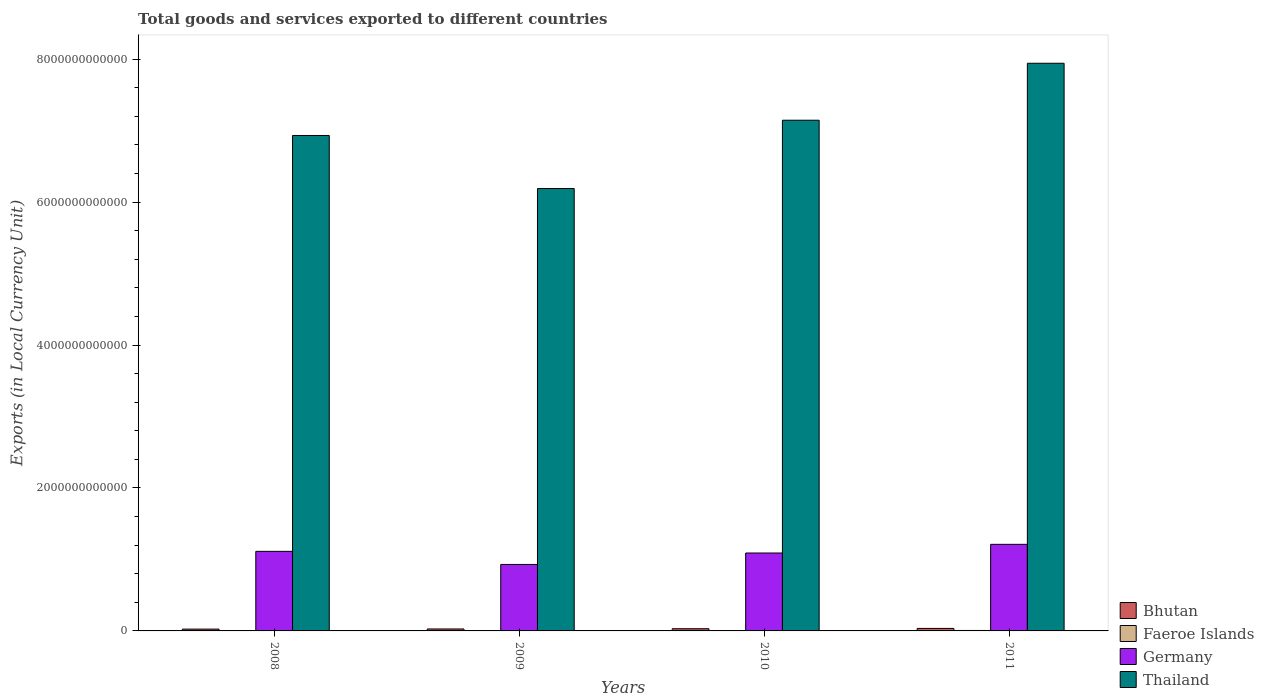How many different coloured bars are there?
Provide a short and direct response. 4. How many groups of bars are there?
Your response must be concise. 4. How many bars are there on the 4th tick from the left?
Keep it short and to the point. 4. What is the label of the 3rd group of bars from the left?
Offer a very short reply. 2010. What is the Amount of goods and services exports in Thailand in 2010?
Provide a short and direct response. 7.15e+12. Across all years, what is the maximum Amount of goods and services exports in Thailand?
Keep it short and to the point. 7.94e+12. Across all years, what is the minimum Amount of goods and services exports in Thailand?
Offer a very short reply. 6.19e+12. In which year was the Amount of goods and services exports in Faeroe Islands minimum?
Give a very brief answer. 2009. What is the total Amount of goods and services exports in Germany in the graph?
Your answer should be compact. 4.34e+12. What is the difference between the Amount of goods and services exports in Germany in 2008 and that in 2009?
Your response must be concise. 1.83e+11. What is the difference between the Amount of goods and services exports in Germany in 2008 and the Amount of goods and services exports in Bhutan in 2009?
Your answer should be very brief. 1.09e+12. What is the average Amount of goods and services exports in Germany per year?
Your response must be concise. 1.09e+12. In the year 2008, what is the difference between the Amount of goods and services exports in Bhutan and Amount of goods and services exports in Faeroe Islands?
Provide a short and direct response. 1.99e+1. What is the ratio of the Amount of goods and services exports in Germany in 2008 to that in 2010?
Offer a very short reply. 1.02. Is the Amount of goods and services exports in Faeroe Islands in 2010 less than that in 2011?
Offer a terse response. Yes. What is the difference between the highest and the second highest Amount of goods and services exports in Faeroe Islands?
Give a very brief answer. 7.42e+08. What is the difference between the highest and the lowest Amount of goods and services exports in Thailand?
Provide a succinct answer. 1.75e+12. In how many years, is the Amount of goods and services exports in Germany greater than the average Amount of goods and services exports in Germany taken over all years?
Your response must be concise. 3. Is the sum of the Amount of goods and services exports in Germany in 2009 and 2011 greater than the maximum Amount of goods and services exports in Faeroe Islands across all years?
Give a very brief answer. Yes. What does the 4th bar from the left in 2008 represents?
Ensure brevity in your answer.  Thailand. What does the 3rd bar from the right in 2009 represents?
Give a very brief answer. Faeroe Islands. What is the difference between two consecutive major ticks on the Y-axis?
Your answer should be compact. 2.00e+12. Are the values on the major ticks of Y-axis written in scientific E-notation?
Make the answer very short. No. Does the graph contain any zero values?
Keep it short and to the point. No. Where does the legend appear in the graph?
Provide a succinct answer. Bottom right. What is the title of the graph?
Provide a short and direct response. Total goods and services exported to different countries. Does "Bolivia" appear as one of the legend labels in the graph?
Give a very brief answer. No. What is the label or title of the Y-axis?
Your answer should be very brief. Exports (in Local Currency Unit). What is the Exports (in Local Currency Unit) of Bhutan in 2008?
Provide a short and direct response. 2.55e+1. What is the Exports (in Local Currency Unit) in Faeroe Islands in 2008?
Make the answer very short. 5.63e+09. What is the Exports (in Local Currency Unit) in Germany in 2008?
Keep it short and to the point. 1.11e+12. What is the Exports (in Local Currency Unit) of Thailand in 2008?
Your answer should be compact. 6.93e+12. What is the Exports (in Local Currency Unit) of Bhutan in 2009?
Offer a very short reply. 2.74e+1. What is the Exports (in Local Currency Unit) in Faeroe Islands in 2009?
Offer a terse response. 5.01e+09. What is the Exports (in Local Currency Unit) of Germany in 2009?
Make the answer very short. 9.30e+11. What is the Exports (in Local Currency Unit) of Thailand in 2009?
Provide a succinct answer. 6.19e+12. What is the Exports (in Local Currency Unit) in Bhutan in 2010?
Offer a very short reply. 3.08e+1. What is the Exports (in Local Currency Unit) in Faeroe Islands in 2010?
Make the answer very short. 5.77e+09. What is the Exports (in Local Currency Unit) in Germany in 2010?
Give a very brief answer. 1.09e+12. What is the Exports (in Local Currency Unit) in Thailand in 2010?
Offer a terse response. 7.15e+12. What is the Exports (in Local Currency Unit) in Bhutan in 2011?
Make the answer very short. 3.50e+1. What is the Exports (in Local Currency Unit) in Faeroe Islands in 2011?
Ensure brevity in your answer.  6.51e+09. What is the Exports (in Local Currency Unit) of Germany in 2011?
Provide a succinct answer. 1.21e+12. What is the Exports (in Local Currency Unit) in Thailand in 2011?
Give a very brief answer. 7.94e+12. Across all years, what is the maximum Exports (in Local Currency Unit) in Bhutan?
Your answer should be compact. 3.50e+1. Across all years, what is the maximum Exports (in Local Currency Unit) of Faeroe Islands?
Offer a terse response. 6.51e+09. Across all years, what is the maximum Exports (in Local Currency Unit) of Germany?
Offer a terse response. 1.21e+12. Across all years, what is the maximum Exports (in Local Currency Unit) of Thailand?
Provide a succinct answer. 7.94e+12. Across all years, what is the minimum Exports (in Local Currency Unit) of Bhutan?
Offer a very short reply. 2.55e+1. Across all years, what is the minimum Exports (in Local Currency Unit) in Faeroe Islands?
Offer a very short reply. 5.01e+09. Across all years, what is the minimum Exports (in Local Currency Unit) in Germany?
Your answer should be very brief. 9.30e+11. Across all years, what is the minimum Exports (in Local Currency Unit) of Thailand?
Provide a succinct answer. 6.19e+12. What is the total Exports (in Local Currency Unit) in Bhutan in the graph?
Offer a very short reply. 1.19e+11. What is the total Exports (in Local Currency Unit) in Faeroe Islands in the graph?
Make the answer very short. 2.29e+1. What is the total Exports (in Local Currency Unit) of Germany in the graph?
Your answer should be compact. 4.34e+12. What is the total Exports (in Local Currency Unit) in Thailand in the graph?
Offer a very short reply. 2.82e+13. What is the difference between the Exports (in Local Currency Unit) in Bhutan in 2008 and that in 2009?
Your response must be concise. -1.88e+09. What is the difference between the Exports (in Local Currency Unit) of Faeroe Islands in 2008 and that in 2009?
Provide a short and direct response. 6.21e+08. What is the difference between the Exports (in Local Currency Unit) of Germany in 2008 and that in 2009?
Give a very brief answer. 1.83e+11. What is the difference between the Exports (in Local Currency Unit) of Thailand in 2008 and that in 2009?
Provide a succinct answer. 7.42e+11. What is the difference between the Exports (in Local Currency Unit) in Bhutan in 2008 and that in 2010?
Provide a succinct answer. -5.29e+09. What is the difference between the Exports (in Local Currency Unit) in Faeroe Islands in 2008 and that in 2010?
Keep it short and to the point. -1.39e+08. What is the difference between the Exports (in Local Currency Unit) in Germany in 2008 and that in 2010?
Provide a short and direct response. 2.32e+1. What is the difference between the Exports (in Local Currency Unit) in Thailand in 2008 and that in 2010?
Keep it short and to the point. -2.13e+11. What is the difference between the Exports (in Local Currency Unit) in Bhutan in 2008 and that in 2011?
Offer a terse response. -9.52e+09. What is the difference between the Exports (in Local Currency Unit) of Faeroe Islands in 2008 and that in 2011?
Keep it short and to the point. -8.81e+08. What is the difference between the Exports (in Local Currency Unit) of Germany in 2008 and that in 2011?
Offer a very short reply. -9.82e+1. What is the difference between the Exports (in Local Currency Unit) of Thailand in 2008 and that in 2011?
Give a very brief answer. -1.01e+12. What is the difference between the Exports (in Local Currency Unit) of Bhutan in 2009 and that in 2010?
Offer a terse response. -3.41e+09. What is the difference between the Exports (in Local Currency Unit) in Faeroe Islands in 2009 and that in 2010?
Give a very brief answer. -7.60e+08. What is the difference between the Exports (in Local Currency Unit) of Germany in 2009 and that in 2010?
Keep it short and to the point. -1.60e+11. What is the difference between the Exports (in Local Currency Unit) in Thailand in 2009 and that in 2010?
Your response must be concise. -9.55e+11. What is the difference between the Exports (in Local Currency Unit) in Bhutan in 2009 and that in 2011?
Your answer should be compact. -7.64e+09. What is the difference between the Exports (in Local Currency Unit) of Faeroe Islands in 2009 and that in 2011?
Give a very brief answer. -1.50e+09. What is the difference between the Exports (in Local Currency Unit) in Germany in 2009 and that in 2011?
Give a very brief answer. -2.81e+11. What is the difference between the Exports (in Local Currency Unit) of Thailand in 2009 and that in 2011?
Ensure brevity in your answer.  -1.75e+12. What is the difference between the Exports (in Local Currency Unit) of Bhutan in 2010 and that in 2011?
Your answer should be compact. -4.23e+09. What is the difference between the Exports (in Local Currency Unit) of Faeroe Islands in 2010 and that in 2011?
Offer a terse response. -7.42e+08. What is the difference between the Exports (in Local Currency Unit) of Germany in 2010 and that in 2011?
Give a very brief answer. -1.21e+11. What is the difference between the Exports (in Local Currency Unit) of Thailand in 2010 and that in 2011?
Provide a succinct answer. -7.97e+11. What is the difference between the Exports (in Local Currency Unit) in Bhutan in 2008 and the Exports (in Local Currency Unit) in Faeroe Islands in 2009?
Make the answer very short. 2.05e+1. What is the difference between the Exports (in Local Currency Unit) of Bhutan in 2008 and the Exports (in Local Currency Unit) of Germany in 2009?
Your response must be concise. -9.05e+11. What is the difference between the Exports (in Local Currency Unit) of Bhutan in 2008 and the Exports (in Local Currency Unit) of Thailand in 2009?
Give a very brief answer. -6.16e+12. What is the difference between the Exports (in Local Currency Unit) of Faeroe Islands in 2008 and the Exports (in Local Currency Unit) of Germany in 2009?
Offer a very short reply. -9.24e+11. What is the difference between the Exports (in Local Currency Unit) of Faeroe Islands in 2008 and the Exports (in Local Currency Unit) of Thailand in 2009?
Ensure brevity in your answer.  -6.18e+12. What is the difference between the Exports (in Local Currency Unit) of Germany in 2008 and the Exports (in Local Currency Unit) of Thailand in 2009?
Give a very brief answer. -5.08e+12. What is the difference between the Exports (in Local Currency Unit) of Bhutan in 2008 and the Exports (in Local Currency Unit) of Faeroe Islands in 2010?
Your answer should be very brief. 1.97e+1. What is the difference between the Exports (in Local Currency Unit) of Bhutan in 2008 and the Exports (in Local Currency Unit) of Germany in 2010?
Give a very brief answer. -1.06e+12. What is the difference between the Exports (in Local Currency Unit) of Bhutan in 2008 and the Exports (in Local Currency Unit) of Thailand in 2010?
Give a very brief answer. -7.12e+12. What is the difference between the Exports (in Local Currency Unit) of Faeroe Islands in 2008 and the Exports (in Local Currency Unit) of Germany in 2010?
Give a very brief answer. -1.08e+12. What is the difference between the Exports (in Local Currency Unit) in Faeroe Islands in 2008 and the Exports (in Local Currency Unit) in Thailand in 2010?
Give a very brief answer. -7.14e+12. What is the difference between the Exports (in Local Currency Unit) of Germany in 2008 and the Exports (in Local Currency Unit) of Thailand in 2010?
Keep it short and to the point. -6.03e+12. What is the difference between the Exports (in Local Currency Unit) of Bhutan in 2008 and the Exports (in Local Currency Unit) of Faeroe Islands in 2011?
Make the answer very short. 1.90e+1. What is the difference between the Exports (in Local Currency Unit) in Bhutan in 2008 and the Exports (in Local Currency Unit) in Germany in 2011?
Make the answer very short. -1.19e+12. What is the difference between the Exports (in Local Currency Unit) of Bhutan in 2008 and the Exports (in Local Currency Unit) of Thailand in 2011?
Ensure brevity in your answer.  -7.92e+12. What is the difference between the Exports (in Local Currency Unit) in Faeroe Islands in 2008 and the Exports (in Local Currency Unit) in Germany in 2011?
Give a very brief answer. -1.21e+12. What is the difference between the Exports (in Local Currency Unit) of Faeroe Islands in 2008 and the Exports (in Local Currency Unit) of Thailand in 2011?
Keep it short and to the point. -7.94e+12. What is the difference between the Exports (in Local Currency Unit) of Germany in 2008 and the Exports (in Local Currency Unit) of Thailand in 2011?
Make the answer very short. -6.83e+12. What is the difference between the Exports (in Local Currency Unit) in Bhutan in 2009 and the Exports (in Local Currency Unit) in Faeroe Islands in 2010?
Your response must be concise. 2.16e+1. What is the difference between the Exports (in Local Currency Unit) in Bhutan in 2009 and the Exports (in Local Currency Unit) in Germany in 2010?
Your response must be concise. -1.06e+12. What is the difference between the Exports (in Local Currency Unit) in Bhutan in 2009 and the Exports (in Local Currency Unit) in Thailand in 2010?
Offer a very short reply. -7.12e+12. What is the difference between the Exports (in Local Currency Unit) in Faeroe Islands in 2009 and the Exports (in Local Currency Unit) in Germany in 2010?
Your answer should be compact. -1.09e+12. What is the difference between the Exports (in Local Currency Unit) in Faeroe Islands in 2009 and the Exports (in Local Currency Unit) in Thailand in 2010?
Your response must be concise. -7.14e+12. What is the difference between the Exports (in Local Currency Unit) of Germany in 2009 and the Exports (in Local Currency Unit) of Thailand in 2010?
Offer a very short reply. -6.22e+12. What is the difference between the Exports (in Local Currency Unit) in Bhutan in 2009 and the Exports (in Local Currency Unit) in Faeroe Islands in 2011?
Provide a short and direct response. 2.09e+1. What is the difference between the Exports (in Local Currency Unit) of Bhutan in 2009 and the Exports (in Local Currency Unit) of Germany in 2011?
Offer a terse response. -1.18e+12. What is the difference between the Exports (in Local Currency Unit) of Bhutan in 2009 and the Exports (in Local Currency Unit) of Thailand in 2011?
Offer a very short reply. -7.92e+12. What is the difference between the Exports (in Local Currency Unit) in Faeroe Islands in 2009 and the Exports (in Local Currency Unit) in Germany in 2011?
Offer a very short reply. -1.21e+12. What is the difference between the Exports (in Local Currency Unit) of Faeroe Islands in 2009 and the Exports (in Local Currency Unit) of Thailand in 2011?
Offer a terse response. -7.94e+12. What is the difference between the Exports (in Local Currency Unit) in Germany in 2009 and the Exports (in Local Currency Unit) in Thailand in 2011?
Keep it short and to the point. -7.01e+12. What is the difference between the Exports (in Local Currency Unit) of Bhutan in 2010 and the Exports (in Local Currency Unit) of Faeroe Islands in 2011?
Your answer should be compact. 2.43e+1. What is the difference between the Exports (in Local Currency Unit) of Bhutan in 2010 and the Exports (in Local Currency Unit) of Germany in 2011?
Provide a short and direct response. -1.18e+12. What is the difference between the Exports (in Local Currency Unit) in Bhutan in 2010 and the Exports (in Local Currency Unit) in Thailand in 2011?
Your answer should be compact. -7.91e+12. What is the difference between the Exports (in Local Currency Unit) in Faeroe Islands in 2010 and the Exports (in Local Currency Unit) in Germany in 2011?
Provide a succinct answer. -1.21e+12. What is the difference between the Exports (in Local Currency Unit) in Faeroe Islands in 2010 and the Exports (in Local Currency Unit) in Thailand in 2011?
Make the answer very short. -7.94e+12. What is the difference between the Exports (in Local Currency Unit) in Germany in 2010 and the Exports (in Local Currency Unit) in Thailand in 2011?
Keep it short and to the point. -6.85e+12. What is the average Exports (in Local Currency Unit) of Bhutan per year?
Ensure brevity in your answer.  2.97e+1. What is the average Exports (in Local Currency Unit) of Faeroe Islands per year?
Your answer should be very brief. 5.73e+09. What is the average Exports (in Local Currency Unit) in Germany per year?
Your answer should be compact. 1.09e+12. What is the average Exports (in Local Currency Unit) of Thailand per year?
Your answer should be very brief. 7.05e+12. In the year 2008, what is the difference between the Exports (in Local Currency Unit) in Bhutan and Exports (in Local Currency Unit) in Faeroe Islands?
Offer a very short reply. 1.99e+1. In the year 2008, what is the difference between the Exports (in Local Currency Unit) in Bhutan and Exports (in Local Currency Unit) in Germany?
Make the answer very short. -1.09e+12. In the year 2008, what is the difference between the Exports (in Local Currency Unit) in Bhutan and Exports (in Local Currency Unit) in Thailand?
Make the answer very short. -6.91e+12. In the year 2008, what is the difference between the Exports (in Local Currency Unit) in Faeroe Islands and Exports (in Local Currency Unit) in Germany?
Provide a short and direct response. -1.11e+12. In the year 2008, what is the difference between the Exports (in Local Currency Unit) in Faeroe Islands and Exports (in Local Currency Unit) in Thailand?
Keep it short and to the point. -6.93e+12. In the year 2008, what is the difference between the Exports (in Local Currency Unit) in Germany and Exports (in Local Currency Unit) in Thailand?
Your answer should be very brief. -5.82e+12. In the year 2009, what is the difference between the Exports (in Local Currency Unit) in Bhutan and Exports (in Local Currency Unit) in Faeroe Islands?
Provide a short and direct response. 2.24e+1. In the year 2009, what is the difference between the Exports (in Local Currency Unit) of Bhutan and Exports (in Local Currency Unit) of Germany?
Offer a very short reply. -9.03e+11. In the year 2009, what is the difference between the Exports (in Local Currency Unit) in Bhutan and Exports (in Local Currency Unit) in Thailand?
Offer a terse response. -6.16e+12. In the year 2009, what is the difference between the Exports (in Local Currency Unit) in Faeroe Islands and Exports (in Local Currency Unit) in Germany?
Ensure brevity in your answer.  -9.25e+11. In the year 2009, what is the difference between the Exports (in Local Currency Unit) of Faeroe Islands and Exports (in Local Currency Unit) of Thailand?
Give a very brief answer. -6.19e+12. In the year 2009, what is the difference between the Exports (in Local Currency Unit) of Germany and Exports (in Local Currency Unit) of Thailand?
Your answer should be compact. -5.26e+12. In the year 2010, what is the difference between the Exports (in Local Currency Unit) in Bhutan and Exports (in Local Currency Unit) in Faeroe Islands?
Provide a succinct answer. 2.50e+1. In the year 2010, what is the difference between the Exports (in Local Currency Unit) of Bhutan and Exports (in Local Currency Unit) of Germany?
Your answer should be compact. -1.06e+12. In the year 2010, what is the difference between the Exports (in Local Currency Unit) in Bhutan and Exports (in Local Currency Unit) in Thailand?
Offer a very short reply. -7.11e+12. In the year 2010, what is the difference between the Exports (in Local Currency Unit) of Faeroe Islands and Exports (in Local Currency Unit) of Germany?
Your response must be concise. -1.08e+12. In the year 2010, what is the difference between the Exports (in Local Currency Unit) of Faeroe Islands and Exports (in Local Currency Unit) of Thailand?
Offer a very short reply. -7.14e+12. In the year 2010, what is the difference between the Exports (in Local Currency Unit) of Germany and Exports (in Local Currency Unit) of Thailand?
Your answer should be very brief. -6.06e+12. In the year 2011, what is the difference between the Exports (in Local Currency Unit) of Bhutan and Exports (in Local Currency Unit) of Faeroe Islands?
Offer a terse response. 2.85e+1. In the year 2011, what is the difference between the Exports (in Local Currency Unit) in Bhutan and Exports (in Local Currency Unit) in Germany?
Your response must be concise. -1.18e+12. In the year 2011, what is the difference between the Exports (in Local Currency Unit) in Bhutan and Exports (in Local Currency Unit) in Thailand?
Keep it short and to the point. -7.91e+12. In the year 2011, what is the difference between the Exports (in Local Currency Unit) in Faeroe Islands and Exports (in Local Currency Unit) in Germany?
Offer a terse response. -1.20e+12. In the year 2011, what is the difference between the Exports (in Local Currency Unit) in Faeroe Islands and Exports (in Local Currency Unit) in Thailand?
Give a very brief answer. -7.94e+12. In the year 2011, what is the difference between the Exports (in Local Currency Unit) in Germany and Exports (in Local Currency Unit) in Thailand?
Keep it short and to the point. -6.73e+12. What is the ratio of the Exports (in Local Currency Unit) in Bhutan in 2008 to that in 2009?
Your response must be concise. 0.93. What is the ratio of the Exports (in Local Currency Unit) of Faeroe Islands in 2008 to that in 2009?
Keep it short and to the point. 1.12. What is the ratio of the Exports (in Local Currency Unit) in Germany in 2008 to that in 2009?
Ensure brevity in your answer.  1.2. What is the ratio of the Exports (in Local Currency Unit) in Thailand in 2008 to that in 2009?
Provide a short and direct response. 1.12. What is the ratio of the Exports (in Local Currency Unit) in Bhutan in 2008 to that in 2010?
Ensure brevity in your answer.  0.83. What is the ratio of the Exports (in Local Currency Unit) of Faeroe Islands in 2008 to that in 2010?
Offer a terse response. 0.98. What is the ratio of the Exports (in Local Currency Unit) of Germany in 2008 to that in 2010?
Offer a terse response. 1.02. What is the ratio of the Exports (in Local Currency Unit) in Thailand in 2008 to that in 2010?
Offer a terse response. 0.97. What is the ratio of the Exports (in Local Currency Unit) in Bhutan in 2008 to that in 2011?
Offer a very short reply. 0.73. What is the ratio of the Exports (in Local Currency Unit) in Faeroe Islands in 2008 to that in 2011?
Offer a very short reply. 0.86. What is the ratio of the Exports (in Local Currency Unit) of Germany in 2008 to that in 2011?
Your answer should be compact. 0.92. What is the ratio of the Exports (in Local Currency Unit) of Thailand in 2008 to that in 2011?
Make the answer very short. 0.87. What is the ratio of the Exports (in Local Currency Unit) in Bhutan in 2009 to that in 2010?
Offer a very short reply. 0.89. What is the ratio of the Exports (in Local Currency Unit) of Faeroe Islands in 2009 to that in 2010?
Provide a short and direct response. 0.87. What is the ratio of the Exports (in Local Currency Unit) in Germany in 2009 to that in 2010?
Provide a succinct answer. 0.85. What is the ratio of the Exports (in Local Currency Unit) of Thailand in 2009 to that in 2010?
Offer a terse response. 0.87. What is the ratio of the Exports (in Local Currency Unit) in Bhutan in 2009 to that in 2011?
Your answer should be compact. 0.78. What is the ratio of the Exports (in Local Currency Unit) in Faeroe Islands in 2009 to that in 2011?
Your response must be concise. 0.77. What is the ratio of the Exports (in Local Currency Unit) of Germany in 2009 to that in 2011?
Provide a succinct answer. 0.77. What is the ratio of the Exports (in Local Currency Unit) of Thailand in 2009 to that in 2011?
Offer a very short reply. 0.78. What is the ratio of the Exports (in Local Currency Unit) of Bhutan in 2010 to that in 2011?
Your answer should be very brief. 0.88. What is the ratio of the Exports (in Local Currency Unit) of Faeroe Islands in 2010 to that in 2011?
Keep it short and to the point. 0.89. What is the ratio of the Exports (in Local Currency Unit) of Germany in 2010 to that in 2011?
Keep it short and to the point. 0.9. What is the ratio of the Exports (in Local Currency Unit) of Thailand in 2010 to that in 2011?
Your response must be concise. 0.9. What is the difference between the highest and the second highest Exports (in Local Currency Unit) of Bhutan?
Keep it short and to the point. 4.23e+09. What is the difference between the highest and the second highest Exports (in Local Currency Unit) of Faeroe Islands?
Ensure brevity in your answer.  7.42e+08. What is the difference between the highest and the second highest Exports (in Local Currency Unit) of Germany?
Provide a succinct answer. 9.82e+1. What is the difference between the highest and the second highest Exports (in Local Currency Unit) of Thailand?
Keep it short and to the point. 7.97e+11. What is the difference between the highest and the lowest Exports (in Local Currency Unit) of Bhutan?
Provide a short and direct response. 9.52e+09. What is the difference between the highest and the lowest Exports (in Local Currency Unit) of Faeroe Islands?
Keep it short and to the point. 1.50e+09. What is the difference between the highest and the lowest Exports (in Local Currency Unit) in Germany?
Offer a terse response. 2.81e+11. What is the difference between the highest and the lowest Exports (in Local Currency Unit) in Thailand?
Provide a succinct answer. 1.75e+12. 